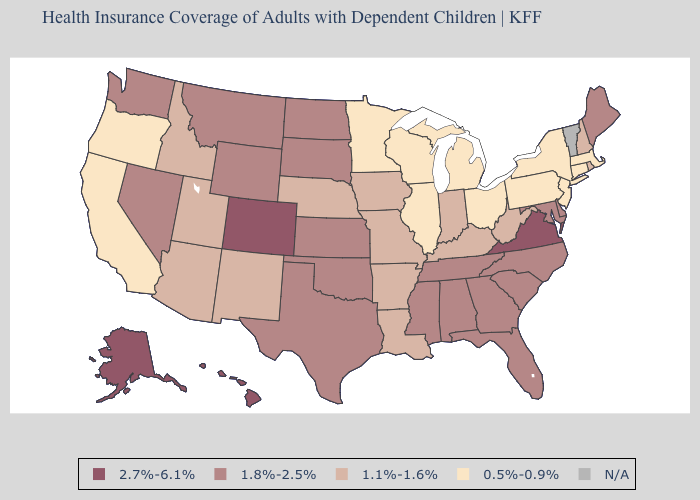Is the legend a continuous bar?
Give a very brief answer. No. What is the lowest value in states that border Idaho?
Short answer required. 0.5%-0.9%. Which states hav the highest value in the Northeast?
Short answer required. Maine. What is the lowest value in the USA?
Write a very short answer. 0.5%-0.9%. Among the states that border Texas , which have the lowest value?
Write a very short answer. Arkansas, Louisiana, New Mexico. Does Kentucky have the lowest value in the South?
Short answer required. Yes. What is the lowest value in the West?
Quick response, please. 0.5%-0.9%. What is the value of West Virginia?
Answer briefly. 1.1%-1.6%. What is the value of Virginia?
Short answer required. 2.7%-6.1%. Among the states that border Delaware , does Maryland have the lowest value?
Write a very short answer. No. Does New York have the highest value in the Northeast?
Short answer required. No. What is the highest value in the USA?
Answer briefly. 2.7%-6.1%. Which states have the lowest value in the USA?
Keep it brief. California, Connecticut, Illinois, Massachusetts, Michigan, Minnesota, New Jersey, New York, Ohio, Oregon, Pennsylvania, Wisconsin. 